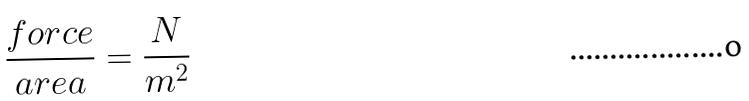<formula> <loc_0><loc_0><loc_500><loc_500>\frac { f o r c e } { a r e a } = \frac { N } { m ^ { 2 } }</formula> 